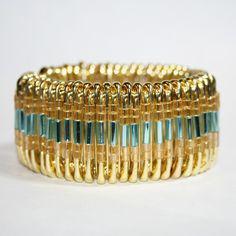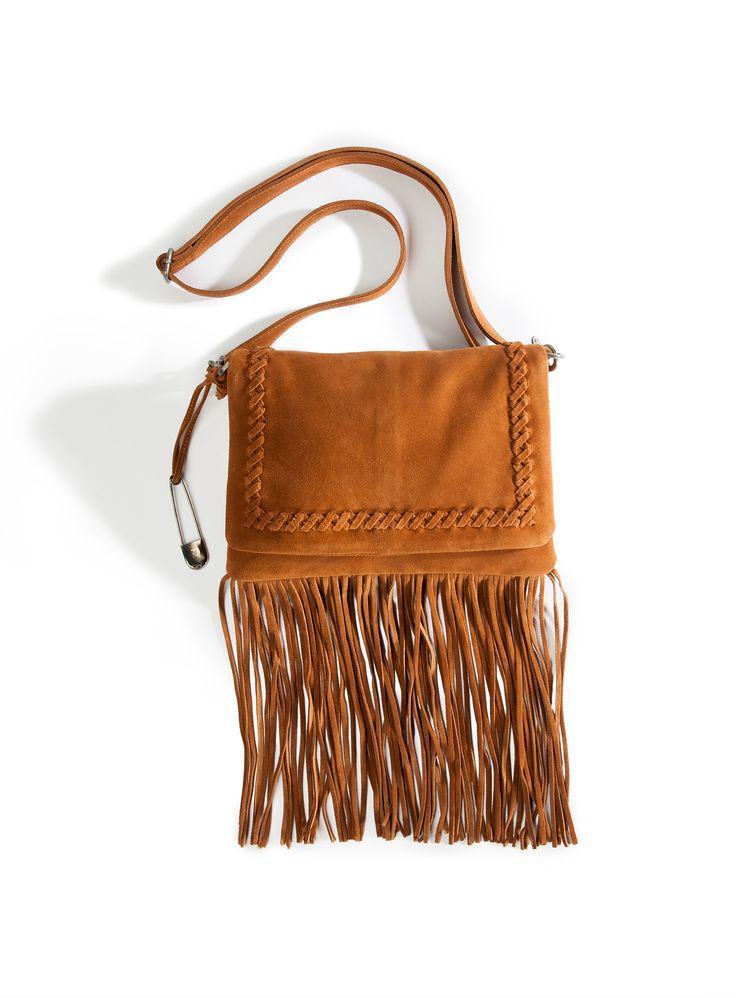The first image is the image on the left, the second image is the image on the right. Given the left and right images, does the statement "An image shows a bracelet made of one color of safety pins, strung with beads." hold true? Answer yes or no. Yes. The first image is the image on the left, the second image is the image on the right. Considering the images on both sides, is "One picture features jewelry made from safety pins that is meant to be worn around one's wrist." valid? Answer yes or no. Yes. 